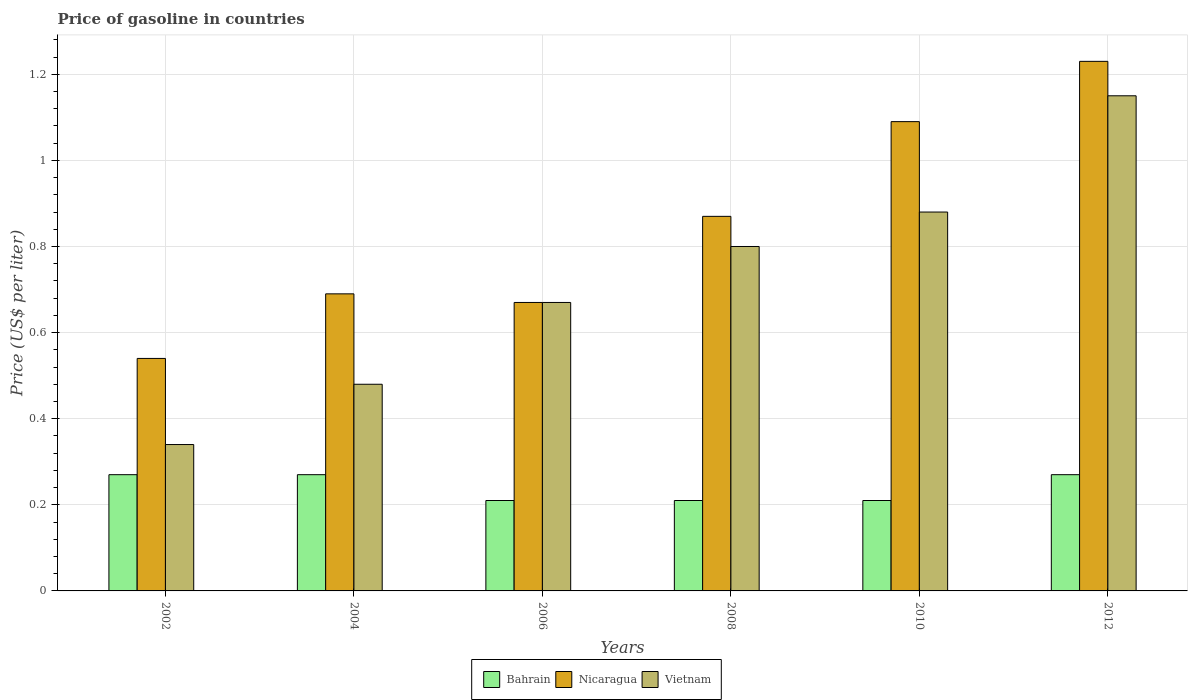How many different coloured bars are there?
Provide a succinct answer. 3. How many groups of bars are there?
Offer a very short reply. 6. How many bars are there on the 2nd tick from the right?
Offer a very short reply. 3. What is the label of the 4th group of bars from the left?
Ensure brevity in your answer.  2008. In how many cases, is the number of bars for a given year not equal to the number of legend labels?
Make the answer very short. 0. What is the price of gasoline in Nicaragua in 2012?
Give a very brief answer. 1.23. Across all years, what is the maximum price of gasoline in Bahrain?
Your response must be concise. 0.27. Across all years, what is the minimum price of gasoline in Nicaragua?
Your answer should be very brief. 0.54. In which year was the price of gasoline in Bahrain minimum?
Make the answer very short. 2006. What is the total price of gasoline in Nicaragua in the graph?
Keep it short and to the point. 5.09. What is the difference between the price of gasoline in Nicaragua in 2006 and that in 2012?
Offer a very short reply. -0.56. What is the difference between the price of gasoline in Bahrain in 2006 and the price of gasoline in Nicaragua in 2004?
Provide a short and direct response. -0.48. What is the average price of gasoline in Bahrain per year?
Your response must be concise. 0.24. In the year 2002, what is the difference between the price of gasoline in Nicaragua and price of gasoline in Bahrain?
Provide a succinct answer. 0.27. What is the ratio of the price of gasoline in Bahrain in 2002 to that in 2008?
Give a very brief answer. 1.29. What is the difference between the highest and the lowest price of gasoline in Vietnam?
Provide a succinct answer. 0.81. Is the sum of the price of gasoline in Vietnam in 2004 and 2006 greater than the maximum price of gasoline in Nicaragua across all years?
Your answer should be very brief. No. What does the 2nd bar from the left in 2012 represents?
Your answer should be very brief. Nicaragua. What does the 3rd bar from the right in 2006 represents?
Offer a very short reply. Bahrain. Are all the bars in the graph horizontal?
Your answer should be compact. No. How many years are there in the graph?
Offer a terse response. 6. Are the values on the major ticks of Y-axis written in scientific E-notation?
Your response must be concise. No. Does the graph contain any zero values?
Your answer should be very brief. No. Does the graph contain grids?
Your response must be concise. Yes. How are the legend labels stacked?
Your answer should be very brief. Horizontal. What is the title of the graph?
Your response must be concise. Price of gasoline in countries. What is the label or title of the X-axis?
Ensure brevity in your answer.  Years. What is the label or title of the Y-axis?
Your answer should be compact. Price (US$ per liter). What is the Price (US$ per liter) of Bahrain in 2002?
Your response must be concise. 0.27. What is the Price (US$ per liter) in Nicaragua in 2002?
Your answer should be very brief. 0.54. What is the Price (US$ per liter) of Vietnam in 2002?
Give a very brief answer. 0.34. What is the Price (US$ per liter) in Bahrain in 2004?
Keep it short and to the point. 0.27. What is the Price (US$ per liter) of Nicaragua in 2004?
Make the answer very short. 0.69. What is the Price (US$ per liter) of Vietnam in 2004?
Keep it short and to the point. 0.48. What is the Price (US$ per liter) of Bahrain in 2006?
Provide a short and direct response. 0.21. What is the Price (US$ per liter) in Nicaragua in 2006?
Your answer should be compact. 0.67. What is the Price (US$ per liter) of Vietnam in 2006?
Provide a succinct answer. 0.67. What is the Price (US$ per liter) of Bahrain in 2008?
Give a very brief answer. 0.21. What is the Price (US$ per liter) of Nicaragua in 2008?
Offer a terse response. 0.87. What is the Price (US$ per liter) in Vietnam in 2008?
Offer a terse response. 0.8. What is the Price (US$ per liter) of Bahrain in 2010?
Your answer should be compact. 0.21. What is the Price (US$ per liter) of Nicaragua in 2010?
Offer a terse response. 1.09. What is the Price (US$ per liter) in Vietnam in 2010?
Make the answer very short. 0.88. What is the Price (US$ per liter) of Bahrain in 2012?
Keep it short and to the point. 0.27. What is the Price (US$ per liter) in Nicaragua in 2012?
Offer a very short reply. 1.23. What is the Price (US$ per liter) of Vietnam in 2012?
Your response must be concise. 1.15. Across all years, what is the maximum Price (US$ per liter) of Bahrain?
Your answer should be compact. 0.27. Across all years, what is the maximum Price (US$ per liter) in Nicaragua?
Offer a very short reply. 1.23. Across all years, what is the maximum Price (US$ per liter) in Vietnam?
Make the answer very short. 1.15. Across all years, what is the minimum Price (US$ per liter) of Bahrain?
Ensure brevity in your answer.  0.21. Across all years, what is the minimum Price (US$ per liter) in Nicaragua?
Make the answer very short. 0.54. Across all years, what is the minimum Price (US$ per liter) of Vietnam?
Provide a short and direct response. 0.34. What is the total Price (US$ per liter) of Bahrain in the graph?
Give a very brief answer. 1.44. What is the total Price (US$ per liter) of Nicaragua in the graph?
Your answer should be compact. 5.09. What is the total Price (US$ per liter) in Vietnam in the graph?
Provide a short and direct response. 4.32. What is the difference between the Price (US$ per liter) in Nicaragua in 2002 and that in 2004?
Give a very brief answer. -0.15. What is the difference between the Price (US$ per liter) in Vietnam in 2002 and that in 2004?
Provide a succinct answer. -0.14. What is the difference between the Price (US$ per liter) of Bahrain in 2002 and that in 2006?
Provide a short and direct response. 0.06. What is the difference between the Price (US$ per liter) of Nicaragua in 2002 and that in 2006?
Make the answer very short. -0.13. What is the difference between the Price (US$ per liter) of Vietnam in 2002 and that in 2006?
Offer a very short reply. -0.33. What is the difference between the Price (US$ per liter) of Nicaragua in 2002 and that in 2008?
Your answer should be very brief. -0.33. What is the difference between the Price (US$ per liter) in Vietnam in 2002 and that in 2008?
Your response must be concise. -0.46. What is the difference between the Price (US$ per liter) in Nicaragua in 2002 and that in 2010?
Offer a very short reply. -0.55. What is the difference between the Price (US$ per liter) in Vietnam in 2002 and that in 2010?
Make the answer very short. -0.54. What is the difference between the Price (US$ per liter) of Bahrain in 2002 and that in 2012?
Your answer should be compact. 0. What is the difference between the Price (US$ per liter) in Nicaragua in 2002 and that in 2012?
Ensure brevity in your answer.  -0.69. What is the difference between the Price (US$ per liter) of Vietnam in 2002 and that in 2012?
Provide a succinct answer. -0.81. What is the difference between the Price (US$ per liter) in Nicaragua in 2004 and that in 2006?
Provide a short and direct response. 0.02. What is the difference between the Price (US$ per liter) of Vietnam in 2004 and that in 2006?
Offer a very short reply. -0.19. What is the difference between the Price (US$ per liter) in Bahrain in 2004 and that in 2008?
Offer a very short reply. 0.06. What is the difference between the Price (US$ per liter) of Nicaragua in 2004 and that in 2008?
Keep it short and to the point. -0.18. What is the difference between the Price (US$ per liter) of Vietnam in 2004 and that in 2008?
Offer a terse response. -0.32. What is the difference between the Price (US$ per liter) of Bahrain in 2004 and that in 2012?
Keep it short and to the point. 0. What is the difference between the Price (US$ per liter) of Nicaragua in 2004 and that in 2012?
Give a very brief answer. -0.54. What is the difference between the Price (US$ per liter) in Vietnam in 2004 and that in 2012?
Ensure brevity in your answer.  -0.67. What is the difference between the Price (US$ per liter) of Bahrain in 2006 and that in 2008?
Give a very brief answer. 0. What is the difference between the Price (US$ per liter) in Nicaragua in 2006 and that in 2008?
Provide a short and direct response. -0.2. What is the difference between the Price (US$ per liter) of Vietnam in 2006 and that in 2008?
Make the answer very short. -0.13. What is the difference between the Price (US$ per liter) of Bahrain in 2006 and that in 2010?
Give a very brief answer. 0. What is the difference between the Price (US$ per liter) of Nicaragua in 2006 and that in 2010?
Your answer should be compact. -0.42. What is the difference between the Price (US$ per liter) of Vietnam in 2006 and that in 2010?
Your response must be concise. -0.21. What is the difference between the Price (US$ per liter) of Bahrain in 2006 and that in 2012?
Your answer should be very brief. -0.06. What is the difference between the Price (US$ per liter) of Nicaragua in 2006 and that in 2012?
Give a very brief answer. -0.56. What is the difference between the Price (US$ per liter) in Vietnam in 2006 and that in 2012?
Offer a terse response. -0.48. What is the difference between the Price (US$ per liter) of Nicaragua in 2008 and that in 2010?
Offer a terse response. -0.22. What is the difference between the Price (US$ per liter) in Vietnam in 2008 and that in 2010?
Your response must be concise. -0.08. What is the difference between the Price (US$ per liter) in Bahrain in 2008 and that in 2012?
Your answer should be very brief. -0.06. What is the difference between the Price (US$ per liter) of Nicaragua in 2008 and that in 2012?
Give a very brief answer. -0.36. What is the difference between the Price (US$ per liter) of Vietnam in 2008 and that in 2012?
Your response must be concise. -0.35. What is the difference between the Price (US$ per liter) in Bahrain in 2010 and that in 2012?
Give a very brief answer. -0.06. What is the difference between the Price (US$ per liter) of Nicaragua in 2010 and that in 2012?
Your answer should be compact. -0.14. What is the difference between the Price (US$ per liter) in Vietnam in 2010 and that in 2012?
Your answer should be compact. -0.27. What is the difference between the Price (US$ per liter) in Bahrain in 2002 and the Price (US$ per liter) in Nicaragua in 2004?
Keep it short and to the point. -0.42. What is the difference between the Price (US$ per liter) of Bahrain in 2002 and the Price (US$ per liter) of Vietnam in 2004?
Keep it short and to the point. -0.21. What is the difference between the Price (US$ per liter) in Nicaragua in 2002 and the Price (US$ per liter) in Vietnam in 2006?
Your response must be concise. -0.13. What is the difference between the Price (US$ per liter) in Bahrain in 2002 and the Price (US$ per liter) in Nicaragua in 2008?
Your answer should be compact. -0.6. What is the difference between the Price (US$ per liter) in Bahrain in 2002 and the Price (US$ per liter) in Vietnam in 2008?
Your response must be concise. -0.53. What is the difference between the Price (US$ per liter) in Nicaragua in 2002 and the Price (US$ per liter) in Vietnam in 2008?
Ensure brevity in your answer.  -0.26. What is the difference between the Price (US$ per liter) of Bahrain in 2002 and the Price (US$ per liter) of Nicaragua in 2010?
Offer a very short reply. -0.82. What is the difference between the Price (US$ per liter) of Bahrain in 2002 and the Price (US$ per liter) of Vietnam in 2010?
Keep it short and to the point. -0.61. What is the difference between the Price (US$ per liter) in Nicaragua in 2002 and the Price (US$ per liter) in Vietnam in 2010?
Give a very brief answer. -0.34. What is the difference between the Price (US$ per liter) in Bahrain in 2002 and the Price (US$ per liter) in Nicaragua in 2012?
Give a very brief answer. -0.96. What is the difference between the Price (US$ per liter) of Bahrain in 2002 and the Price (US$ per liter) of Vietnam in 2012?
Keep it short and to the point. -0.88. What is the difference between the Price (US$ per liter) of Nicaragua in 2002 and the Price (US$ per liter) of Vietnam in 2012?
Your answer should be compact. -0.61. What is the difference between the Price (US$ per liter) in Bahrain in 2004 and the Price (US$ per liter) in Nicaragua in 2006?
Make the answer very short. -0.4. What is the difference between the Price (US$ per liter) of Bahrain in 2004 and the Price (US$ per liter) of Vietnam in 2006?
Offer a terse response. -0.4. What is the difference between the Price (US$ per liter) in Nicaragua in 2004 and the Price (US$ per liter) in Vietnam in 2006?
Provide a short and direct response. 0.02. What is the difference between the Price (US$ per liter) of Bahrain in 2004 and the Price (US$ per liter) of Nicaragua in 2008?
Give a very brief answer. -0.6. What is the difference between the Price (US$ per liter) in Bahrain in 2004 and the Price (US$ per liter) in Vietnam in 2008?
Give a very brief answer. -0.53. What is the difference between the Price (US$ per liter) of Nicaragua in 2004 and the Price (US$ per liter) of Vietnam in 2008?
Your answer should be compact. -0.11. What is the difference between the Price (US$ per liter) in Bahrain in 2004 and the Price (US$ per liter) in Nicaragua in 2010?
Provide a succinct answer. -0.82. What is the difference between the Price (US$ per liter) in Bahrain in 2004 and the Price (US$ per liter) in Vietnam in 2010?
Ensure brevity in your answer.  -0.61. What is the difference between the Price (US$ per liter) in Nicaragua in 2004 and the Price (US$ per liter) in Vietnam in 2010?
Your answer should be compact. -0.19. What is the difference between the Price (US$ per liter) in Bahrain in 2004 and the Price (US$ per liter) in Nicaragua in 2012?
Ensure brevity in your answer.  -0.96. What is the difference between the Price (US$ per liter) of Bahrain in 2004 and the Price (US$ per liter) of Vietnam in 2012?
Offer a terse response. -0.88. What is the difference between the Price (US$ per liter) of Nicaragua in 2004 and the Price (US$ per liter) of Vietnam in 2012?
Keep it short and to the point. -0.46. What is the difference between the Price (US$ per liter) in Bahrain in 2006 and the Price (US$ per liter) in Nicaragua in 2008?
Offer a terse response. -0.66. What is the difference between the Price (US$ per liter) of Bahrain in 2006 and the Price (US$ per liter) of Vietnam in 2008?
Provide a succinct answer. -0.59. What is the difference between the Price (US$ per liter) of Nicaragua in 2006 and the Price (US$ per liter) of Vietnam in 2008?
Your response must be concise. -0.13. What is the difference between the Price (US$ per liter) of Bahrain in 2006 and the Price (US$ per liter) of Nicaragua in 2010?
Ensure brevity in your answer.  -0.88. What is the difference between the Price (US$ per liter) of Bahrain in 2006 and the Price (US$ per liter) of Vietnam in 2010?
Ensure brevity in your answer.  -0.67. What is the difference between the Price (US$ per liter) in Nicaragua in 2006 and the Price (US$ per liter) in Vietnam in 2010?
Give a very brief answer. -0.21. What is the difference between the Price (US$ per liter) in Bahrain in 2006 and the Price (US$ per liter) in Nicaragua in 2012?
Your response must be concise. -1.02. What is the difference between the Price (US$ per liter) of Bahrain in 2006 and the Price (US$ per liter) of Vietnam in 2012?
Provide a succinct answer. -0.94. What is the difference between the Price (US$ per liter) in Nicaragua in 2006 and the Price (US$ per liter) in Vietnam in 2012?
Keep it short and to the point. -0.48. What is the difference between the Price (US$ per liter) in Bahrain in 2008 and the Price (US$ per liter) in Nicaragua in 2010?
Keep it short and to the point. -0.88. What is the difference between the Price (US$ per liter) of Bahrain in 2008 and the Price (US$ per liter) of Vietnam in 2010?
Your answer should be compact. -0.67. What is the difference between the Price (US$ per liter) of Nicaragua in 2008 and the Price (US$ per liter) of Vietnam in 2010?
Your answer should be compact. -0.01. What is the difference between the Price (US$ per liter) of Bahrain in 2008 and the Price (US$ per liter) of Nicaragua in 2012?
Your answer should be very brief. -1.02. What is the difference between the Price (US$ per liter) in Bahrain in 2008 and the Price (US$ per liter) in Vietnam in 2012?
Provide a short and direct response. -0.94. What is the difference between the Price (US$ per liter) in Nicaragua in 2008 and the Price (US$ per liter) in Vietnam in 2012?
Keep it short and to the point. -0.28. What is the difference between the Price (US$ per liter) of Bahrain in 2010 and the Price (US$ per liter) of Nicaragua in 2012?
Offer a terse response. -1.02. What is the difference between the Price (US$ per liter) of Bahrain in 2010 and the Price (US$ per liter) of Vietnam in 2012?
Offer a terse response. -0.94. What is the difference between the Price (US$ per liter) in Nicaragua in 2010 and the Price (US$ per liter) in Vietnam in 2012?
Make the answer very short. -0.06. What is the average Price (US$ per liter) in Bahrain per year?
Give a very brief answer. 0.24. What is the average Price (US$ per liter) in Nicaragua per year?
Your response must be concise. 0.85. What is the average Price (US$ per liter) of Vietnam per year?
Your answer should be very brief. 0.72. In the year 2002, what is the difference between the Price (US$ per liter) of Bahrain and Price (US$ per liter) of Nicaragua?
Your answer should be compact. -0.27. In the year 2002, what is the difference between the Price (US$ per liter) of Bahrain and Price (US$ per liter) of Vietnam?
Provide a succinct answer. -0.07. In the year 2004, what is the difference between the Price (US$ per liter) in Bahrain and Price (US$ per liter) in Nicaragua?
Give a very brief answer. -0.42. In the year 2004, what is the difference between the Price (US$ per liter) of Bahrain and Price (US$ per liter) of Vietnam?
Give a very brief answer. -0.21. In the year 2004, what is the difference between the Price (US$ per liter) of Nicaragua and Price (US$ per liter) of Vietnam?
Keep it short and to the point. 0.21. In the year 2006, what is the difference between the Price (US$ per liter) in Bahrain and Price (US$ per liter) in Nicaragua?
Your answer should be compact. -0.46. In the year 2006, what is the difference between the Price (US$ per liter) of Bahrain and Price (US$ per liter) of Vietnam?
Your answer should be compact. -0.46. In the year 2006, what is the difference between the Price (US$ per liter) of Nicaragua and Price (US$ per liter) of Vietnam?
Keep it short and to the point. 0. In the year 2008, what is the difference between the Price (US$ per liter) in Bahrain and Price (US$ per liter) in Nicaragua?
Give a very brief answer. -0.66. In the year 2008, what is the difference between the Price (US$ per liter) in Bahrain and Price (US$ per liter) in Vietnam?
Your response must be concise. -0.59. In the year 2008, what is the difference between the Price (US$ per liter) in Nicaragua and Price (US$ per liter) in Vietnam?
Give a very brief answer. 0.07. In the year 2010, what is the difference between the Price (US$ per liter) in Bahrain and Price (US$ per liter) in Nicaragua?
Your response must be concise. -0.88. In the year 2010, what is the difference between the Price (US$ per liter) in Bahrain and Price (US$ per liter) in Vietnam?
Provide a short and direct response. -0.67. In the year 2010, what is the difference between the Price (US$ per liter) of Nicaragua and Price (US$ per liter) of Vietnam?
Keep it short and to the point. 0.21. In the year 2012, what is the difference between the Price (US$ per liter) of Bahrain and Price (US$ per liter) of Nicaragua?
Keep it short and to the point. -0.96. In the year 2012, what is the difference between the Price (US$ per liter) of Bahrain and Price (US$ per liter) of Vietnam?
Ensure brevity in your answer.  -0.88. In the year 2012, what is the difference between the Price (US$ per liter) of Nicaragua and Price (US$ per liter) of Vietnam?
Your response must be concise. 0.08. What is the ratio of the Price (US$ per liter) in Bahrain in 2002 to that in 2004?
Make the answer very short. 1. What is the ratio of the Price (US$ per liter) in Nicaragua in 2002 to that in 2004?
Your response must be concise. 0.78. What is the ratio of the Price (US$ per liter) in Vietnam in 2002 to that in 2004?
Provide a succinct answer. 0.71. What is the ratio of the Price (US$ per liter) in Nicaragua in 2002 to that in 2006?
Provide a short and direct response. 0.81. What is the ratio of the Price (US$ per liter) of Vietnam in 2002 to that in 2006?
Provide a short and direct response. 0.51. What is the ratio of the Price (US$ per liter) in Bahrain in 2002 to that in 2008?
Provide a succinct answer. 1.29. What is the ratio of the Price (US$ per liter) in Nicaragua in 2002 to that in 2008?
Your answer should be very brief. 0.62. What is the ratio of the Price (US$ per liter) of Vietnam in 2002 to that in 2008?
Keep it short and to the point. 0.42. What is the ratio of the Price (US$ per liter) of Nicaragua in 2002 to that in 2010?
Make the answer very short. 0.5. What is the ratio of the Price (US$ per liter) in Vietnam in 2002 to that in 2010?
Your answer should be very brief. 0.39. What is the ratio of the Price (US$ per liter) in Nicaragua in 2002 to that in 2012?
Your answer should be compact. 0.44. What is the ratio of the Price (US$ per liter) of Vietnam in 2002 to that in 2012?
Offer a terse response. 0.3. What is the ratio of the Price (US$ per liter) of Nicaragua in 2004 to that in 2006?
Make the answer very short. 1.03. What is the ratio of the Price (US$ per liter) of Vietnam in 2004 to that in 2006?
Ensure brevity in your answer.  0.72. What is the ratio of the Price (US$ per liter) of Bahrain in 2004 to that in 2008?
Provide a short and direct response. 1.29. What is the ratio of the Price (US$ per liter) in Nicaragua in 2004 to that in 2008?
Offer a terse response. 0.79. What is the ratio of the Price (US$ per liter) in Bahrain in 2004 to that in 2010?
Make the answer very short. 1.29. What is the ratio of the Price (US$ per liter) of Nicaragua in 2004 to that in 2010?
Make the answer very short. 0.63. What is the ratio of the Price (US$ per liter) of Vietnam in 2004 to that in 2010?
Provide a short and direct response. 0.55. What is the ratio of the Price (US$ per liter) of Nicaragua in 2004 to that in 2012?
Offer a very short reply. 0.56. What is the ratio of the Price (US$ per liter) in Vietnam in 2004 to that in 2012?
Your answer should be compact. 0.42. What is the ratio of the Price (US$ per liter) in Bahrain in 2006 to that in 2008?
Your answer should be compact. 1. What is the ratio of the Price (US$ per liter) of Nicaragua in 2006 to that in 2008?
Make the answer very short. 0.77. What is the ratio of the Price (US$ per liter) in Vietnam in 2006 to that in 2008?
Ensure brevity in your answer.  0.84. What is the ratio of the Price (US$ per liter) of Nicaragua in 2006 to that in 2010?
Provide a short and direct response. 0.61. What is the ratio of the Price (US$ per liter) of Vietnam in 2006 to that in 2010?
Offer a very short reply. 0.76. What is the ratio of the Price (US$ per liter) of Bahrain in 2006 to that in 2012?
Your answer should be compact. 0.78. What is the ratio of the Price (US$ per liter) of Nicaragua in 2006 to that in 2012?
Your answer should be very brief. 0.54. What is the ratio of the Price (US$ per liter) in Vietnam in 2006 to that in 2012?
Your answer should be very brief. 0.58. What is the ratio of the Price (US$ per liter) of Bahrain in 2008 to that in 2010?
Your answer should be compact. 1. What is the ratio of the Price (US$ per liter) in Nicaragua in 2008 to that in 2010?
Your answer should be very brief. 0.8. What is the ratio of the Price (US$ per liter) of Bahrain in 2008 to that in 2012?
Your response must be concise. 0.78. What is the ratio of the Price (US$ per liter) of Nicaragua in 2008 to that in 2012?
Provide a short and direct response. 0.71. What is the ratio of the Price (US$ per liter) of Vietnam in 2008 to that in 2012?
Keep it short and to the point. 0.7. What is the ratio of the Price (US$ per liter) in Nicaragua in 2010 to that in 2012?
Offer a terse response. 0.89. What is the ratio of the Price (US$ per liter) of Vietnam in 2010 to that in 2012?
Offer a terse response. 0.77. What is the difference between the highest and the second highest Price (US$ per liter) of Nicaragua?
Ensure brevity in your answer.  0.14. What is the difference between the highest and the second highest Price (US$ per liter) of Vietnam?
Provide a succinct answer. 0.27. What is the difference between the highest and the lowest Price (US$ per liter) of Bahrain?
Your answer should be compact. 0.06. What is the difference between the highest and the lowest Price (US$ per liter) in Nicaragua?
Make the answer very short. 0.69. What is the difference between the highest and the lowest Price (US$ per liter) in Vietnam?
Provide a short and direct response. 0.81. 